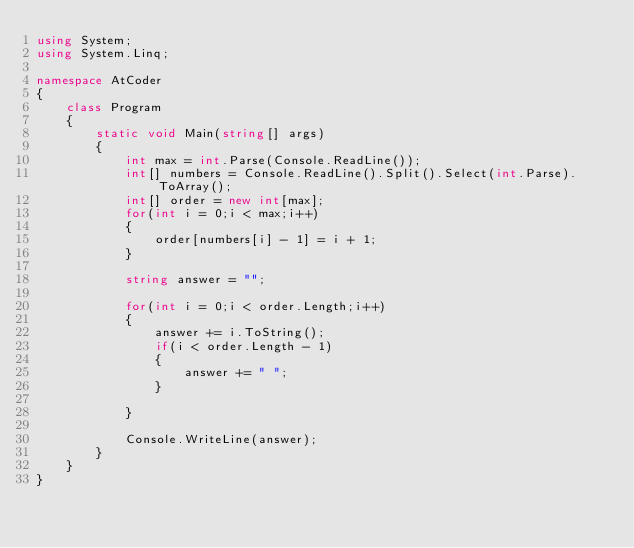<code> <loc_0><loc_0><loc_500><loc_500><_C#_>using System;
using System.Linq;

namespace AtCoder
{
    class Program
    {
        static void Main(string[] args)
        {
            int max = int.Parse(Console.ReadLine());
            int[] numbers = Console.ReadLine().Split().Select(int.Parse).ToArray();
            int[] order = new int[max];
            for(int i = 0;i < max;i++)
            {
                order[numbers[i] - 1] = i + 1;
            }

            string answer = "";

            for(int i = 0;i < order.Length;i++)
            {
                answer += i.ToString();
                if(i < order.Length - 1)
                {
                    answer += " ";
                }

            }

            Console.WriteLine(answer);
        }
    }
}
</code> 